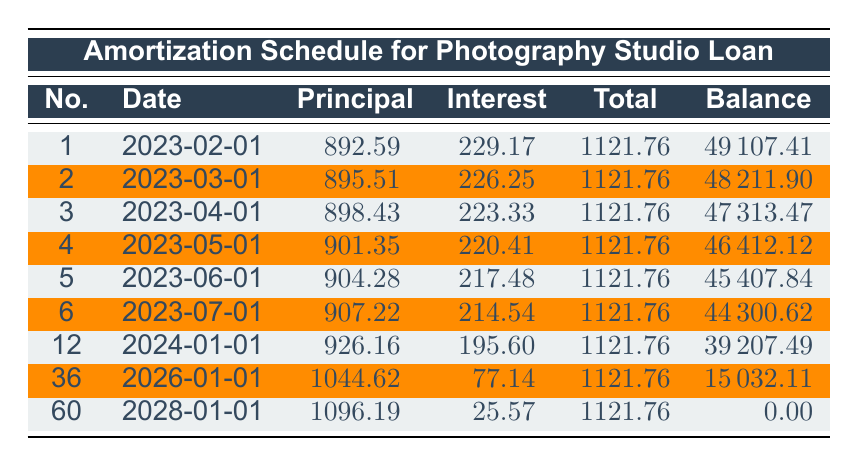What is the total payment amount for the first month? Referring to the first row, the total payment for the first payment number (February 1, 2023) is 1121.76.
Answer: 1121.76 How much principal is paid off in the third month? Looking at the third row, the principal payment for the third payment number (April 1, 2023) is 898.43.
Answer: 898.43 What is the remaining balance after the first year of payments? After 12 months, the remaining balance is noted in the row for payment number 12 (January 1, 2024), which shows a balance of 39207.49.
Answer: 39207.49 Is the interest payment for the final month less than the interest payment for the first month? Comparing the interest payments for payment numbers 1 and 60 (February 1, 2023, and January 1, 2028 respectively), the first month has an interest payment of 229.17, while the final month has an interest payment of 25.57. Since 25.57 is less than 229.17, the answer is yes.
Answer: Yes What is the average principal payment made over the first six months? Summing the principal payments from payment numbers 1 to 6 gives (892.59 + 895.51 + 898.43 + 901.35 + 904.28 + 907.22) = 5299.38. Then, dividing by 6, the average principal payment is 5299.38 / 6 = 883.23.
Answer: 883.23 Over the course of the loan, which month had the highest principal payment, and what was that amount? By examining the rows, the highest principal payment occurs in the 60th payment (January 1, 2028) at 1096.19.
Answer: 1096.19 How much less is the total interest paid in the last payment compared to the first payment? The interest payment for the first payment is 229.17, and for the last payment, it is 25.57. To find the difference, calculate 229.17 - 25.57 = 203.60.
Answer: 203.60 How many total payments are made throughout the duration of the loan? The loan term is 5 years, which translates to 60 monthly payments (12 payments per year * 5 years = 60 payments).
Answer: 60 